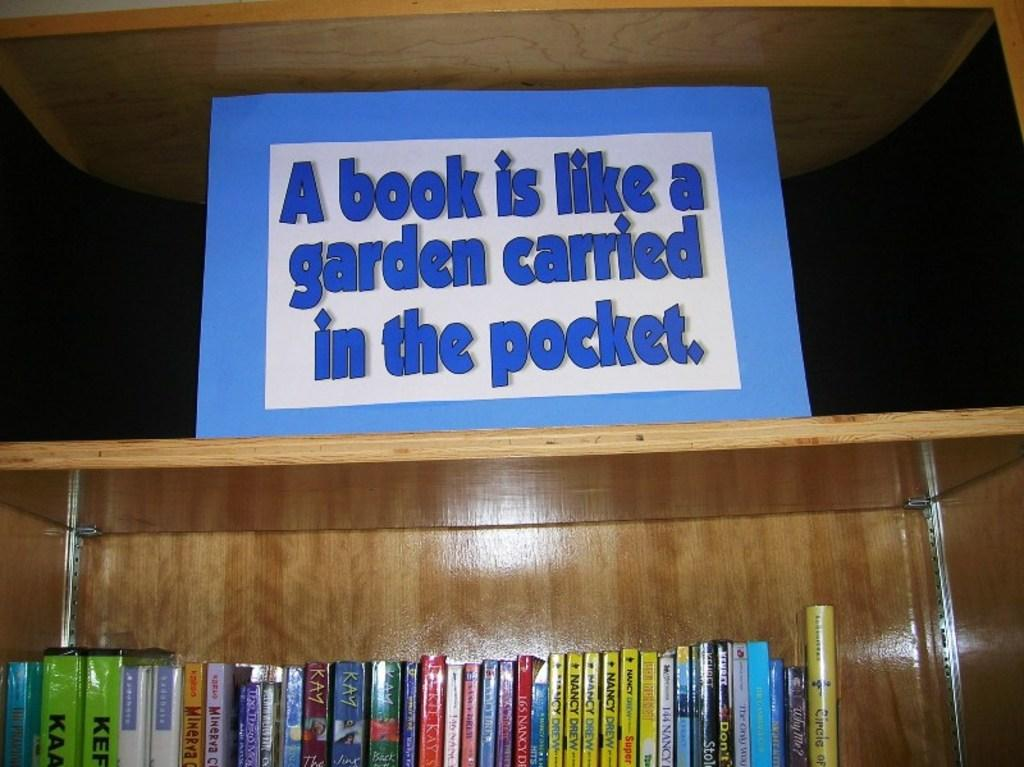<image>
Give a short and clear explanation of the subsequent image. Books under a shelf with a sign that says "A book is like a garden carried in a pocket". 